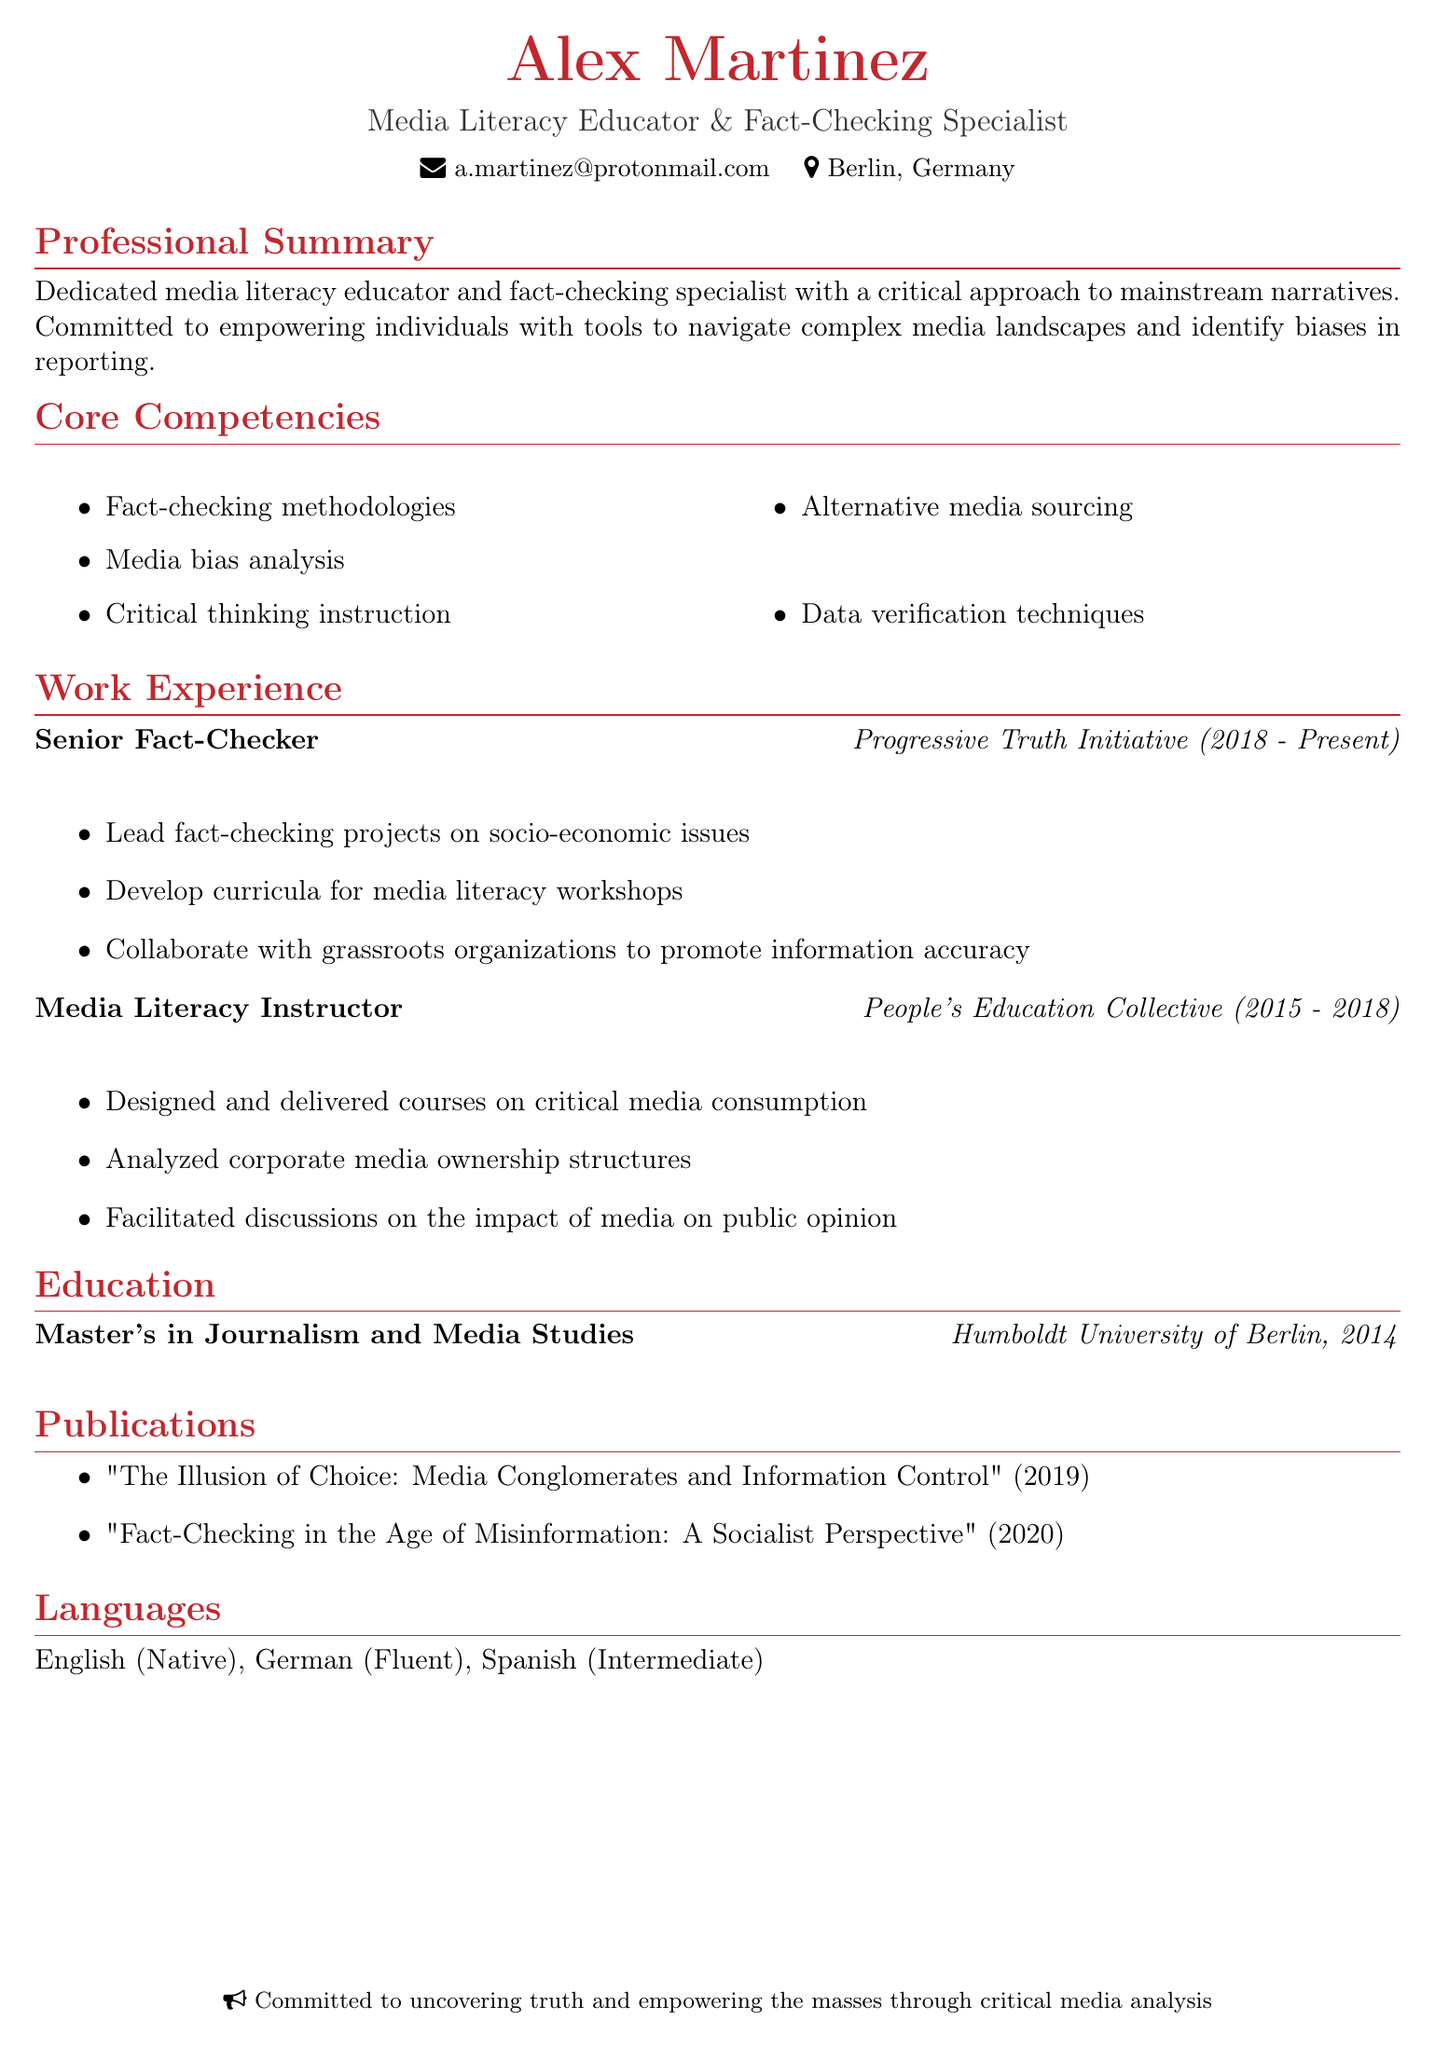what is the name of the individual? The name of the individual is stated prominently at the top of the document.
Answer: Alex Martinez what is Alex Martinez's email address? The email address is provided in the personal information section of the document.
Answer: a.martinez@protonmail.com what is the title of the most recent publication? The titles of the publications are listed, and the most recent one appears at the bottom of the publications section.
Answer: "Fact-Checking in the Age of Misinformation: A Socialist Perspective" how many languages does Alex Martinez speak? The languages section details the languages Alex is proficient in.
Answer: Three what organization did Alex work for from 2015 to 2018? The work experience section includes the name of the organization for that time period.
Answer: People's Education Collective what is Alex's highest degree? The education section indicates the highest academic qualification attained by Alex.
Answer: Master's in Journalism and Media Studies how long has Alex been a Senior Fact-Checker? The work experience section specifies the duration of employment in the current role.
Answer: Five years what is one core competency related to media analysis? The core competencies listed highlight various skills, one of which pertains specifically to media analysis.
Answer: Media bias analysis 